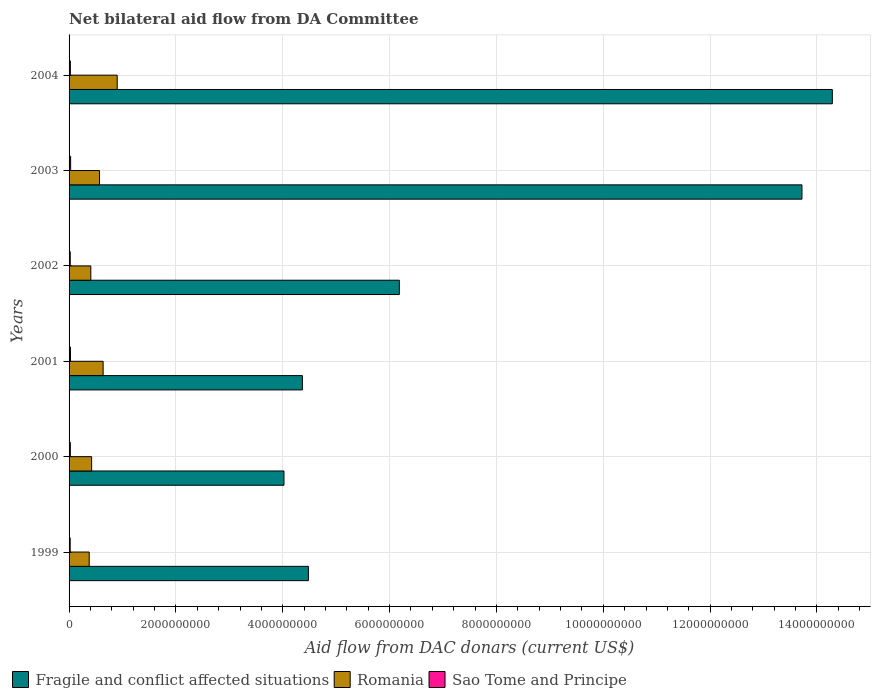Are the number of bars per tick equal to the number of legend labels?
Your answer should be compact. Yes. Are the number of bars on each tick of the Y-axis equal?
Provide a short and direct response. Yes. In how many cases, is the number of bars for a given year not equal to the number of legend labels?
Keep it short and to the point. 0. What is the aid flow in in Fragile and conflict affected situations in 2002?
Provide a short and direct response. 6.18e+09. Across all years, what is the maximum aid flow in in Fragile and conflict affected situations?
Keep it short and to the point. 1.43e+1. Across all years, what is the minimum aid flow in in Fragile and conflict affected situations?
Make the answer very short. 4.02e+09. In which year was the aid flow in in Fragile and conflict affected situations minimum?
Keep it short and to the point. 2000. What is the total aid flow in in Sao Tome and Principe in the graph?
Your response must be concise. 1.47e+08. What is the difference between the aid flow in in Sao Tome and Principe in 2000 and that in 2003?
Ensure brevity in your answer.  -5.55e+06. What is the difference between the aid flow in in Romania in 2004 and the aid flow in in Fragile and conflict affected situations in 2000?
Provide a succinct answer. -3.12e+09. What is the average aid flow in in Sao Tome and Principe per year?
Offer a terse response. 2.44e+07. In the year 2002, what is the difference between the aid flow in in Sao Tome and Principe and aid flow in in Romania?
Your answer should be very brief. -3.85e+08. In how many years, is the aid flow in in Sao Tome and Principe greater than 10800000000 US$?
Make the answer very short. 0. What is the ratio of the aid flow in in Fragile and conflict affected situations in 2002 to that in 2004?
Keep it short and to the point. 0.43. Is the aid flow in in Romania in 2001 less than that in 2002?
Your answer should be very brief. No. What is the difference between the highest and the second highest aid flow in in Romania?
Ensure brevity in your answer.  2.64e+08. What is the difference between the highest and the lowest aid flow in in Sao Tome and Principe?
Give a very brief answer. 8.39e+06. Is the sum of the aid flow in in Romania in 2000 and 2004 greater than the maximum aid flow in in Fragile and conflict affected situations across all years?
Keep it short and to the point. No. What does the 1st bar from the top in 2004 represents?
Give a very brief answer. Sao Tome and Principe. What does the 2nd bar from the bottom in 2001 represents?
Your response must be concise. Romania. Is it the case that in every year, the sum of the aid flow in in Sao Tome and Principe and aid flow in in Fragile and conflict affected situations is greater than the aid flow in in Romania?
Provide a short and direct response. Yes. How many bars are there?
Keep it short and to the point. 18. How many years are there in the graph?
Offer a terse response. 6. Does the graph contain any zero values?
Ensure brevity in your answer.  No. How are the legend labels stacked?
Your response must be concise. Horizontal. What is the title of the graph?
Your response must be concise. Net bilateral aid flow from DA Committee. Does "American Samoa" appear as one of the legend labels in the graph?
Provide a succinct answer. No. What is the label or title of the X-axis?
Your answer should be compact. Aid flow from DAC donars (current US$). What is the Aid flow from DAC donars (current US$) of Fragile and conflict affected situations in 1999?
Make the answer very short. 4.48e+09. What is the Aid flow from DAC donars (current US$) of Romania in 1999?
Your response must be concise. 3.77e+08. What is the Aid flow from DAC donars (current US$) in Sao Tome and Principe in 1999?
Your response must be concise. 2.09e+07. What is the Aid flow from DAC donars (current US$) of Fragile and conflict affected situations in 2000?
Provide a short and direct response. 4.02e+09. What is the Aid flow from DAC donars (current US$) in Romania in 2000?
Keep it short and to the point. 4.22e+08. What is the Aid flow from DAC donars (current US$) of Sao Tome and Principe in 2000?
Your answer should be compact. 2.37e+07. What is the Aid flow from DAC donars (current US$) of Fragile and conflict affected situations in 2001?
Your answer should be very brief. 4.37e+09. What is the Aid flow from DAC donars (current US$) of Romania in 2001?
Ensure brevity in your answer.  6.37e+08. What is the Aid flow from DAC donars (current US$) of Sao Tome and Principe in 2001?
Offer a terse response. 2.69e+07. What is the Aid flow from DAC donars (current US$) of Fragile and conflict affected situations in 2002?
Your response must be concise. 6.18e+09. What is the Aid flow from DAC donars (current US$) of Romania in 2002?
Ensure brevity in your answer.  4.07e+08. What is the Aid flow from DAC donars (current US$) in Sao Tome and Principe in 2002?
Provide a succinct answer. 2.16e+07. What is the Aid flow from DAC donars (current US$) of Fragile and conflict affected situations in 2003?
Provide a succinct answer. 1.37e+1. What is the Aid flow from DAC donars (current US$) in Romania in 2003?
Ensure brevity in your answer.  5.70e+08. What is the Aid flow from DAC donars (current US$) of Sao Tome and Principe in 2003?
Your answer should be compact. 2.93e+07. What is the Aid flow from DAC donars (current US$) of Fragile and conflict affected situations in 2004?
Your answer should be compact. 1.43e+1. What is the Aid flow from DAC donars (current US$) in Romania in 2004?
Provide a short and direct response. 9.01e+08. What is the Aid flow from DAC donars (current US$) of Sao Tome and Principe in 2004?
Offer a terse response. 2.42e+07. Across all years, what is the maximum Aid flow from DAC donars (current US$) of Fragile and conflict affected situations?
Your answer should be very brief. 1.43e+1. Across all years, what is the maximum Aid flow from DAC donars (current US$) of Romania?
Offer a terse response. 9.01e+08. Across all years, what is the maximum Aid flow from DAC donars (current US$) of Sao Tome and Principe?
Make the answer very short. 2.93e+07. Across all years, what is the minimum Aid flow from DAC donars (current US$) in Fragile and conflict affected situations?
Offer a terse response. 4.02e+09. Across all years, what is the minimum Aid flow from DAC donars (current US$) in Romania?
Offer a very short reply. 3.77e+08. Across all years, what is the minimum Aid flow from DAC donars (current US$) of Sao Tome and Principe?
Your answer should be very brief. 2.09e+07. What is the total Aid flow from DAC donars (current US$) of Fragile and conflict affected situations in the graph?
Provide a short and direct response. 4.71e+1. What is the total Aid flow from DAC donars (current US$) of Romania in the graph?
Offer a terse response. 3.32e+09. What is the total Aid flow from DAC donars (current US$) of Sao Tome and Principe in the graph?
Keep it short and to the point. 1.47e+08. What is the difference between the Aid flow from DAC donars (current US$) of Fragile and conflict affected situations in 1999 and that in 2000?
Your answer should be compact. 4.57e+08. What is the difference between the Aid flow from DAC donars (current US$) of Romania in 1999 and that in 2000?
Your response must be concise. -4.55e+07. What is the difference between the Aid flow from DAC donars (current US$) in Sao Tome and Principe in 1999 and that in 2000?
Offer a terse response. -2.84e+06. What is the difference between the Aid flow from DAC donars (current US$) in Fragile and conflict affected situations in 1999 and that in 2001?
Make the answer very short. 1.13e+08. What is the difference between the Aid flow from DAC donars (current US$) in Romania in 1999 and that in 2001?
Give a very brief answer. -2.60e+08. What is the difference between the Aid flow from DAC donars (current US$) in Sao Tome and Principe in 1999 and that in 2001?
Provide a short and direct response. -6.02e+06. What is the difference between the Aid flow from DAC donars (current US$) in Fragile and conflict affected situations in 1999 and that in 2002?
Your answer should be compact. -1.70e+09. What is the difference between the Aid flow from DAC donars (current US$) in Romania in 1999 and that in 2002?
Make the answer very short. -3.01e+07. What is the difference between the Aid flow from DAC donars (current US$) in Sao Tome and Principe in 1999 and that in 2002?
Offer a terse response. -7.70e+05. What is the difference between the Aid flow from DAC donars (current US$) in Fragile and conflict affected situations in 1999 and that in 2003?
Give a very brief answer. -9.24e+09. What is the difference between the Aid flow from DAC donars (current US$) in Romania in 1999 and that in 2003?
Make the answer very short. -1.93e+08. What is the difference between the Aid flow from DAC donars (current US$) in Sao Tome and Principe in 1999 and that in 2003?
Your answer should be compact. -8.39e+06. What is the difference between the Aid flow from DAC donars (current US$) in Fragile and conflict affected situations in 1999 and that in 2004?
Keep it short and to the point. -9.81e+09. What is the difference between the Aid flow from DAC donars (current US$) in Romania in 1999 and that in 2004?
Offer a very short reply. -5.24e+08. What is the difference between the Aid flow from DAC donars (current US$) in Sao Tome and Principe in 1999 and that in 2004?
Your response must be concise. -3.34e+06. What is the difference between the Aid flow from DAC donars (current US$) of Fragile and conflict affected situations in 2000 and that in 2001?
Offer a terse response. -3.45e+08. What is the difference between the Aid flow from DAC donars (current US$) of Romania in 2000 and that in 2001?
Ensure brevity in your answer.  -2.15e+08. What is the difference between the Aid flow from DAC donars (current US$) of Sao Tome and Principe in 2000 and that in 2001?
Offer a terse response. -3.18e+06. What is the difference between the Aid flow from DAC donars (current US$) in Fragile and conflict affected situations in 2000 and that in 2002?
Give a very brief answer. -2.16e+09. What is the difference between the Aid flow from DAC donars (current US$) in Romania in 2000 and that in 2002?
Keep it short and to the point. 1.54e+07. What is the difference between the Aid flow from DAC donars (current US$) in Sao Tome and Principe in 2000 and that in 2002?
Give a very brief answer. 2.07e+06. What is the difference between the Aid flow from DAC donars (current US$) of Fragile and conflict affected situations in 2000 and that in 2003?
Your response must be concise. -9.70e+09. What is the difference between the Aid flow from DAC donars (current US$) in Romania in 2000 and that in 2003?
Provide a succinct answer. -1.48e+08. What is the difference between the Aid flow from DAC donars (current US$) in Sao Tome and Principe in 2000 and that in 2003?
Give a very brief answer. -5.55e+06. What is the difference between the Aid flow from DAC donars (current US$) of Fragile and conflict affected situations in 2000 and that in 2004?
Offer a terse response. -1.03e+1. What is the difference between the Aid flow from DAC donars (current US$) in Romania in 2000 and that in 2004?
Your answer should be compact. -4.79e+08. What is the difference between the Aid flow from DAC donars (current US$) in Sao Tome and Principe in 2000 and that in 2004?
Ensure brevity in your answer.  -5.00e+05. What is the difference between the Aid flow from DAC donars (current US$) in Fragile and conflict affected situations in 2001 and that in 2002?
Provide a short and direct response. -1.82e+09. What is the difference between the Aid flow from DAC donars (current US$) of Romania in 2001 and that in 2002?
Ensure brevity in your answer.  2.30e+08. What is the difference between the Aid flow from DAC donars (current US$) of Sao Tome and Principe in 2001 and that in 2002?
Offer a very short reply. 5.25e+06. What is the difference between the Aid flow from DAC donars (current US$) in Fragile and conflict affected situations in 2001 and that in 2003?
Offer a very short reply. -9.35e+09. What is the difference between the Aid flow from DAC donars (current US$) in Romania in 2001 and that in 2003?
Offer a terse response. 6.73e+07. What is the difference between the Aid flow from DAC donars (current US$) of Sao Tome and Principe in 2001 and that in 2003?
Give a very brief answer. -2.37e+06. What is the difference between the Aid flow from DAC donars (current US$) of Fragile and conflict affected situations in 2001 and that in 2004?
Offer a very short reply. -9.92e+09. What is the difference between the Aid flow from DAC donars (current US$) of Romania in 2001 and that in 2004?
Provide a short and direct response. -2.64e+08. What is the difference between the Aid flow from DAC donars (current US$) of Sao Tome and Principe in 2001 and that in 2004?
Your answer should be compact. 2.68e+06. What is the difference between the Aid flow from DAC donars (current US$) in Fragile and conflict affected situations in 2002 and that in 2003?
Ensure brevity in your answer.  -7.54e+09. What is the difference between the Aid flow from DAC donars (current US$) in Romania in 2002 and that in 2003?
Make the answer very short. -1.63e+08. What is the difference between the Aid flow from DAC donars (current US$) in Sao Tome and Principe in 2002 and that in 2003?
Your answer should be very brief. -7.62e+06. What is the difference between the Aid flow from DAC donars (current US$) in Fragile and conflict affected situations in 2002 and that in 2004?
Your answer should be compact. -8.10e+09. What is the difference between the Aid flow from DAC donars (current US$) in Romania in 2002 and that in 2004?
Provide a short and direct response. -4.94e+08. What is the difference between the Aid flow from DAC donars (current US$) in Sao Tome and Principe in 2002 and that in 2004?
Offer a terse response. -2.57e+06. What is the difference between the Aid flow from DAC donars (current US$) of Fragile and conflict affected situations in 2003 and that in 2004?
Give a very brief answer. -5.68e+08. What is the difference between the Aid flow from DAC donars (current US$) of Romania in 2003 and that in 2004?
Your response must be concise. -3.31e+08. What is the difference between the Aid flow from DAC donars (current US$) in Sao Tome and Principe in 2003 and that in 2004?
Provide a succinct answer. 5.05e+06. What is the difference between the Aid flow from DAC donars (current US$) of Fragile and conflict affected situations in 1999 and the Aid flow from DAC donars (current US$) of Romania in 2000?
Make the answer very short. 4.06e+09. What is the difference between the Aid flow from DAC donars (current US$) of Fragile and conflict affected situations in 1999 and the Aid flow from DAC donars (current US$) of Sao Tome and Principe in 2000?
Your response must be concise. 4.46e+09. What is the difference between the Aid flow from DAC donars (current US$) of Romania in 1999 and the Aid flow from DAC donars (current US$) of Sao Tome and Principe in 2000?
Ensure brevity in your answer.  3.53e+08. What is the difference between the Aid flow from DAC donars (current US$) of Fragile and conflict affected situations in 1999 and the Aid flow from DAC donars (current US$) of Romania in 2001?
Provide a short and direct response. 3.84e+09. What is the difference between the Aid flow from DAC donars (current US$) of Fragile and conflict affected situations in 1999 and the Aid flow from DAC donars (current US$) of Sao Tome and Principe in 2001?
Your response must be concise. 4.45e+09. What is the difference between the Aid flow from DAC donars (current US$) in Romania in 1999 and the Aid flow from DAC donars (current US$) in Sao Tome and Principe in 2001?
Offer a terse response. 3.50e+08. What is the difference between the Aid flow from DAC donars (current US$) in Fragile and conflict affected situations in 1999 and the Aid flow from DAC donars (current US$) in Romania in 2002?
Your answer should be very brief. 4.07e+09. What is the difference between the Aid flow from DAC donars (current US$) of Fragile and conflict affected situations in 1999 and the Aid flow from DAC donars (current US$) of Sao Tome and Principe in 2002?
Your answer should be compact. 4.46e+09. What is the difference between the Aid flow from DAC donars (current US$) of Romania in 1999 and the Aid flow from DAC donars (current US$) of Sao Tome and Principe in 2002?
Provide a short and direct response. 3.55e+08. What is the difference between the Aid flow from DAC donars (current US$) in Fragile and conflict affected situations in 1999 and the Aid flow from DAC donars (current US$) in Romania in 2003?
Offer a very short reply. 3.91e+09. What is the difference between the Aid flow from DAC donars (current US$) in Fragile and conflict affected situations in 1999 and the Aid flow from DAC donars (current US$) in Sao Tome and Principe in 2003?
Your answer should be very brief. 4.45e+09. What is the difference between the Aid flow from DAC donars (current US$) of Romania in 1999 and the Aid flow from DAC donars (current US$) of Sao Tome and Principe in 2003?
Give a very brief answer. 3.48e+08. What is the difference between the Aid flow from DAC donars (current US$) of Fragile and conflict affected situations in 1999 and the Aid flow from DAC donars (current US$) of Romania in 2004?
Ensure brevity in your answer.  3.58e+09. What is the difference between the Aid flow from DAC donars (current US$) in Fragile and conflict affected situations in 1999 and the Aid flow from DAC donars (current US$) in Sao Tome and Principe in 2004?
Your response must be concise. 4.46e+09. What is the difference between the Aid flow from DAC donars (current US$) of Romania in 1999 and the Aid flow from DAC donars (current US$) of Sao Tome and Principe in 2004?
Your response must be concise. 3.53e+08. What is the difference between the Aid flow from DAC donars (current US$) of Fragile and conflict affected situations in 2000 and the Aid flow from DAC donars (current US$) of Romania in 2001?
Offer a very short reply. 3.39e+09. What is the difference between the Aid flow from DAC donars (current US$) of Fragile and conflict affected situations in 2000 and the Aid flow from DAC donars (current US$) of Sao Tome and Principe in 2001?
Give a very brief answer. 4.00e+09. What is the difference between the Aid flow from DAC donars (current US$) of Romania in 2000 and the Aid flow from DAC donars (current US$) of Sao Tome and Principe in 2001?
Your answer should be very brief. 3.96e+08. What is the difference between the Aid flow from DAC donars (current US$) in Fragile and conflict affected situations in 2000 and the Aid flow from DAC donars (current US$) in Romania in 2002?
Offer a terse response. 3.62e+09. What is the difference between the Aid flow from DAC donars (current US$) of Fragile and conflict affected situations in 2000 and the Aid flow from DAC donars (current US$) of Sao Tome and Principe in 2002?
Provide a short and direct response. 4.00e+09. What is the difference between the Aid flow from DAC donars (current US$) of Romania in 2000 and the Aid flow from DAC donars (current US$) of Sao Tome and Principe in 2002?
Ensure brevity in your answer.  4.01e+08. What is the difference between the Aid flow from DAC donars (current US$) of Fragile and conflict affected situations in 2000 and the Aid flow from DAC donars (current US$) of Romania in 2003?
Give a very brief answer. 3.45e+09. What is the difference between the Aid flow from DAC donars (current US$) in Fragile and conflict affected situations in 2000 and the Aid flow from DAC donars (current US$) in Sao Tome and Principe in 2003?
Offer a terse response. 3.99e+09. What is the difference between the Aid flow from DAC donars (current US$) in Romania in 2000 and the Aid flow from DAC donars (current US$) in Sao Tome and Principe in 2003?
Your answer should be very brief. 3.93e+08. What is the difference between the Aid flow from DAC donars (current US$) of Fragile and conflict affected situations in 2000 and the Aid flow from DAC donars (current US$) of Romania in 2004?
Offer a very short reply. 3.12e+09. What is the difference between the Aid flow from DAC donars (current US$) of Fragile and conflict affected situations in 2000 and the Aid flow from DAC donars (current US$) of Sao Tome and Principe in 2004?
Provide a short and direct response. 4.00e+09. What is the difference between the Aid flow from DAC donars (current US$) in Romania in 2000 and the Aid flow from DAC donars (current US$) in Sao Tome and Principe in 2004?
Give a very brief answer. 3.98e+08. What is the difference between the Aid flow from DAC donars (current US$) of Fragile and conflict affected situations in 2001 and the Aid flow from DAC donars (current US$) of Romania in 2002?
Offer a very short reply. 3.96e+09. What is the difference between the Aid flow from DAC donars (current US$) in Fragile and conflict affected situations in 2001 and the Aid flow from DAC donars (current US$) in Sao Tome and Principe in 2002?
Offer a terse response. 4.35e+09. What is the difference between the Aid flow from DAC donars (current US$) of Romania in 2001 and the Aid flow from DAC donars (current US$) of Sao Tome and Principe in 2002?
Give a very brief answer. 6.16e+08. What is the difference between the Aid flow from DAC donars (current US$) of Fragile and conflict affected situations in 2001 and the Aid flow from DAC donars (current US$) of Romania in 2003?
Provide a short and direct response. 3.80e+09. What is the difference between the Aid flow from DAC donars (current US$) of Fragile and conflict affected situations in 2001 and the Aid flow from DAC donars (current US$) of Sao Tome and Principe in 2003?
Offer a terse response. 4.34e+09. What is the difference between the Aid flow from DAC donars (current US$) of Romania in 2001 and the Aid flow from DAC donars (current US$) of Sao Tome and Principe in 2003?
Keep it short and to the point. 6.08e+08. What is the difference between the Aid flow from DAC donars (current US$) in Fragile and conflict affected situations in 2001 and the Aid flow from DAC donars (current US$) in Romania in 2004?
Make the answer very short. 3.47e+09. What is the difference between the Aid flow from DAC donars (current US$) of Fragile and conflict affected situations in 2001 and the Aid flow from DAC donars (current US$) of Sao Tome and Principe in 2004?
Give a very brief answer. 4.34e+09. What is the difference between the Aid flow from DAC donars (current US$) in Romania in 2001 and the Aid flow from DAC donars (current US$) in Sao Tome and Principe in 2004?
Offer a terse response. 6.13e+08. What is the difference between the Aid flow from DAC donars (current US$) in Fragile and conflict affected situations in 2002 and the Aid flow from DAC donars (current US$) in Romania in 2003?
Your response must be concise. 5.61e+09. What is the difference between the Aid flow from DAC donars (current US$) in Fragile and conflict affected situations in 2002 and the Aid flow from DAC donars (current US$) in Sao Tome and Principe in 2003?
Keep it short and to the point. 6.15e+09. What is the difference between the Aid flow from DAC donars (current US$) of Romania in 2002 and the Aid flow from DAC donars (current US$) of Sao Tome and Principe in 2003?
Your answer should be compact. 3.78e+08. What is the difference between the Aid flow from DAC donars (current US$) of Fragile and conflict affected situations in 2002 and the Aid flow from DAC donars (current US$) of Romania in 2004?
Give a very brief answer. 5.28e+09. What is the difference between the Aid flow from DAC donars (current US$) in Fragile and conflict affected situations in 2002 and the Aid flow from DAC donars (current US$) in Sao Tome and Principe in 2004?
Your answer should be very brief. 6.16e+09. What is the difference between the Aid flow from DAC donars (current US$) in Romania in 2002 and the Aid flow from DAC donars (current US$) in Sao Tome and Principe in 2004?
Your answer should be very brief. 3.83e+08. What is the difference between the Aid flow from DAC donars (current US$) of Fragile and conflict affected situations in 2003 and the Aid flow from DAC donars (current US$) of Romania in 2004?
Your answer should be very brief. 1.28e+1. What is the difference between the Aid flow from DAC donars (current US$) of Fragile and conflict affected situations in 2003 and the Aid flow from DAC donars (current US$) of Sao Tome and Principe in 2004?
Offer a very short reply. 1.37e+1. What is the difference between the Aid flow from DAC donars (current US$) in Romania in 2003 and the Aid flow from DAC donars (current US$) in Sao Tome and Principe in 2004?
Give a very brief answer. 5.46e+08. What is the average Aid flow from DAC donars (current US$) in Fragile and conflict affected situations per year?
Give a very brief answer. 7.84e+09. What is the average Aid flow from DAC donars (current US$) in Romania per year?
Provide a succinct answer. 5.53e+08. What is the average Aid flow from DAC donars (current US$) in Sao Tome and Principe per year?
Ensure brevity in your answer.  2.44e+07. In the year 1999, what is the difference between the Aid flow from DAC donars (current US$) of Fragile and conflict affected situations and Aid flow from DAC donars (current US$) of Romania?
Offer a terse response. 4.10e+09. In the year 1999, what is the difference between the Aid flow from DAC donars (current US$) of Fragile and conflict affected situations and Aid flow from DAC donars (current US$) of Sao Tome and Principe?
Make the answer very short. 4.46e+09. In the year 1999, what is the difference between the Aid flow from DAC donars (current US$) of Romania and Aid flow from DAC donars (current US$) of Sao Tome and Principe?
Your answer should be compact. 3.56e+08. In the year 2000, what is the difference between the Aid flow from DAC donars (current US$) of Fragile and conflict affected situations and Aid flow from DAC donars (current US$) of Romania?
Your answer should be very brief. 3.60e+09. In the year 2000, what is the difference between the Aid flow from DAC donars (current US$) in Fragile and conflict affected situations and Aid flow from DAC donars (current US$) in Sao Tome and Principe?
Provide a short and direct response. 4.00e+09. In the year 2000, what is the difference between the Aid flow from DAC donars (current US$) of Romania and Aid flow from DAC donars (current US$) of Sao Tome and Principe?
Your answer should be compact. 3.99e+08. In the year 2001, what is the difference between the Aid flow from DAC donars (current US$) of Fragile and conflict affected situations and Aid flow from DAC donars (current US$) of Romania?
Offer a very short reply. 3.73e+09. In the year 2001, what is the difference between the Aid flow from DAC donars (current US$) of Fragile and conflict affected situations and Aid flow from DAC donars (current US$) of Sao Tome and Principe?
Make the answer very short. 4.34e+09. In the year 2001, what is the difference between the Aid flow from DAC donars (current US$) in Romania and Aid flow from DAC donars (current US$) in Sao Tome and Principe?
Keep it short and to the point. 6.11e+08. In the year 2002, what is the difference between the Aid flow from DAC donars (current US$) in Fragile and conflict affected situations and Aid flow from DAC donars (current US$) in Romania?
Your response must be concise. 5.78e+09. In the year 2002, what is the difference between the Aid flow from DAC donars (current US$) of Fragile and conflict affected situations and Aid flow from DAC donars (current US$) of Sao Tome and Principe?
Offer a very short reply. 6.16e+09. In the year 2002, what is the difference between the Aid flow from DAC donars (current US$) in Romania and Aid flow from DAC donars (current US$) in Sao Tome and Principe?
Your answer should be very brief. 3.85e+08. In the year 2003, what is the difference between the Aid flow from DAC donars (current US$) of Fragile and conflict affected situations and Aid flow from DAC donars (current US$) of Romania?
Offer a very short reply. 1.31e+1. In the year 2003, what is the difference between the Aid flow from DAC donars (current US$) in Fragile and conflict affected situations and Aid flow from DAC donars (current US$) in Sao Tome and Principe?
Give a very brief answer. 1.37e+1. In the year 2003, what is the difference between the Aid flow from DAC donars (current US$) of Romania and Aid flow from DAC donars (current US$) of Sao Tome and Principe?
Offer a very short reply. 5.41e+08. In the year 2004, what is the difference between the Aid flow from DAC donars (current US$) of Fragile and conflict affected situations and Aid flow from DAC donars (current US$) of Romania?
Provide a succinct answer. 1.34e+1. In the year 2004, what is the difference between the Aid flow from DAC donars (current US$) in Fragile and conflict affected situations and Aid flow from DAC donars (current US$) in Sao Tome and Principe?
Give a very brief answer. 1.43e+1. In the year 2004, what is the difference between the Aid flow from DAC donars (current US$) in Romania and Aid flow from DAC donars (current US$) in Sao Tome and Principe?
Make the answer very short. 8.77e+08. What is the ratio of the Aid flow from DAC donars (current US$) of Fragile and conflict affected situations in 1999 to that in 2000?
Your answer should be very brief. 1.11. What is the ratio of the Aid flow from DAC donars (current US$) of Romania in 1999 to that in 2000?
Your answer should be very brief. 0.89. What is the ratio of the Aid flow from DAC donars (current US$) of Sao Tome and Principe in 1999 to that in 2000?
Offer a terse response. 0.88. What is the ratio of the Aid flow from DAC donars (current US$) of Fragile and conflict affected situations in 1999 to that in 2001?
Provide a short and direct response. 1.03. What is the ratio of the Aid flow from DAC donars (current US$) of Romania in 1999 to that in 2001?
Keep it short and to the point. 0.59. What is the ratio of the Aid flow from DAC donars (current US$) of Sao Tome and Principe in 1999 to that in 2001?
Your response must be concise. 0.78. What is the ratio of the Aid flow from DAC donars (current US$) of Fragile and conflict affected situations in 1999 to that in 2002?
Give a very brief answer. 0.72. What is the ratio of the Aid flow from DAC donars (current US$) of Romania in 1999 to that in 2002?
Keep it short and to the point. 0.93. What is the ratio of the Aid flow from DAC donars (current US$) in Sao Tome and Principe in 1999 to that in 2002?
Your answer should be very brief. 0.96. What is the ratio of the Aid flow from DAC donars (current US$) in Fragile and conflict affected situations in 1999 to that in 2003?
Give a very brief answer. 0.33. What is the ratio of the Aid flow from DAC donars (current US$) in Romania in 1999 to that in 2003?
Your response must be concise. 0.66. What is the ratio of the Aid flow from DAC donars (current US$) of Sao Tome and Principe in 1999 to that in 2003?
Offer a terse response. 0.71. What is the ratio of the Aid flow from DAC donars (current US$) of Fragile and conflict affected situations in 1999 to that in 2004?
Give a very brief answer. 0.31. What is the ratio of the Aid flow from DAC donars (current US$) in Romania in 1999 to that in 2004?
Give a very brief answer. 0.42. What is the ratio of the Aid flow from DAC donars (current US$) in Sao Tome and Principe in 1999 to that in 2004?
Ensure brevity in your answer.  0.86. What is the ratio of the Aid flow from DAC donars (current US$) in Fragile and conflict affected situations in 2000 to that in 2001?
Provide a short and direct response. 0.92. What is the ratio of the Aid flow from DAC donars (current US$) in Romania in 2000 to that in 2001?
Your response must be concise. 0.66. What is the ratio of the Aid flow from DAC donars (current US$) of Sao Tome and Principe in 2000 to that in 2001?
Your response must be concise. 0.88. What is the ratio of the Aid flow from DAC donars (current US$) of Fragile and conflict affected situations in 2000 to that in 2002?
Make the answer very short. 0.65. What is the ratio of the Aid flow from DAC donars (current US$) in Romania in 2000 to that in 2002?
Give a very brief answer. 1.04. What is the ratio of the Aid flow from DAC donars (current US$) of Sao Tome and Principe in 2000 to that in 2002?
Your answer should be compact. 1.1. What is the ratio of the Aid flow from DAC donars (current US$) of Fragile and conflict affected situations in 2000 to that in 2003?
Keep it short and to the point. 0.29. What is the ratio of the Aid flow from DAC donars (current US$) in Romania in 2000 to that in 2003?
Your answer should be compact. 0.74. What is the ratio of the Aid flow from DAC donars (current US$) in Sao Tome and Principe in 2000 to that in 2003?
Keep it short and to the point. 0.81. What is the ratio of the Aid flow from DAC donars (current US$) of Fragile and conflict affected situations in 2000 to that in 2004?
Make the answer very short. 0.28. What is the ratio of the Aid flow from DAC donars (current US$) of Romania in 2000 to that in 2004?
Your answer should be compact. 0.47. What is the ratio of the Aid flow from DAC donars (current US$) of Sao Tome and Principe in 2000 to that in 2004?
Offer a very short reply. 0.98. What is the ratio of the Aid flow from DAC donars (current US$) of Fragile and conflict affected situations in 2001 to that in 2002?
Provide a short and direct response. 0.71. What is the ratio of the Aid flow from DAC donars (current US$) of Romania in 2001 to that in 2002?
Keep it short and to the point. 1.57. What is the ratio of the Aid flow from DAC donars (current US$) in Sao Tome and Principe in 2001 to that in 2002?
Make the answer very short. 1.24. What is the ratio of the Aid flow from DAC donars (current US$) of Fragile and conflict affected situations in 2001 to that in 2003?
Provide a short and direct response. 0.32. What is the ratio of the Aid flow from DAC donars (current US$) in Romania in 2001 to that in 2003?
Your answer should be very brief. 1.12. What is the ratio of the Aid flow from DAC donars (current US$) in Sao Tome and Principe in 2001 to that in 2003?
Provide a short and direct response. 0.92. What is the ratio of the Aid flow from DAC donars (current US$) of Fragile and conflict affected situations in 2001 to that in 2004?
Your answer should be very brief. 0.31. What is the ratio of the Aid flow from DAC donars (current US$) in Romania in 2001 to that in 2004?
Your response must be concise. 0.71. What is the ratio of the Aid flow from DAC donars (current US$) of Sao Tome and Principe in 2001 to that in 2004?
Your response must be concise. 1.11. What is the ratio of the Aid flow from DAC donars (current US$) in Fragile and conflict affected situations in 2002 to that in 2003?
Provide a short and direct response. 0.45. What is the ratio of the Aid flow from DAC donars (current US$) of Romania in 2002 to that in 2003?
Provide a succinct answer. 0.71. What is the ratio of the Aid flow from DAC donars (current US$) of Sao Tome and Principe in 2002 to that in 2003?
Your answer should be compact. 0.74. What is the ratio of the Aid flow from DAC donars (current US$) of Fragile and conflict affected situations in 2002 to that in 2004?
Provide a short and direct response. 0.43. What is the ratio of the Aid flow from DAC donars (current US$) in Romania in 2002 to that in 2004?
Offer a terse response. 0.45. What is the ratio of the Aid flow from DAC donars (current US$) in Sao Tome and Principe in 2002 to that in 2004?
Provide a short and direct response. 0.89. What is the ratio of the Aid flow from DAC donars (current US$) of Fragile and conflict affected situations in 2003 to that in 2004?
Your response must be concise. 0.96. What is the ratio of the Aid flow from DAC donars (current US$) in Romania in 2003 to that in 2004?
Your answer should be very brief. 0.63. What is the ratio of the Aid flow from DAC donars (current US$) in Sao Tome and Principe in 2003 to that in 2004?
Offer a very short reply. 1.21. What is the difference between the highest and the second highest Aid flow from DAC donars (current US$) in Fragile and conflict affected situations?
Ensure brevity in your answer.  5.68e+08. What is the difference between the highest and the second highest Aid flow from DAC donars (current US$) of Romania?
Make the answer very short. 2.64e+08. What is the difference between the highest and the second highest Aid flow from DAC donars (current US$) in Sao Tome and Principe?
Make the answer very short. 2.37e+06. What is the difference between the highest and the lowest Aid flow from DAC donars (current US$) in Fragile and conflict affected situations?
Provide a short and direct response. 1.03e+1. What is the difference between the highest and the lowest Aid flow from DAC donars (current US$) in Romania?
Keep it short and to the point. 5.24e+08. What is the difference between the highest and the lowest Aid flow from DAC donars (current US$) of Sao Tome and Principe?
Provide a succinct answer. 8.39e+06. 